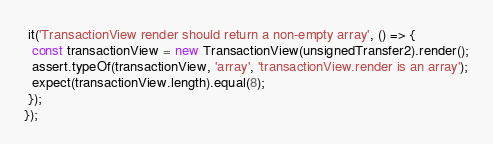<code> <loc_0><loc_0><loc_500><loc_500><_TypeScript_> it('TransactionView render should return a non-empty array', () => {
  const transactionView = new TransactionView(unsignedTransfer2).render();
  assert.typeOf(transactionView, 'array', 'transactionView.render is an array');
  expect(transactionView.length).equal(8);
 });
});
</code> 